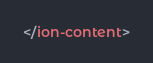<code> <loc_0><loc_0><loc_500><loc_500><_HTML_></ion-content>
</code> 